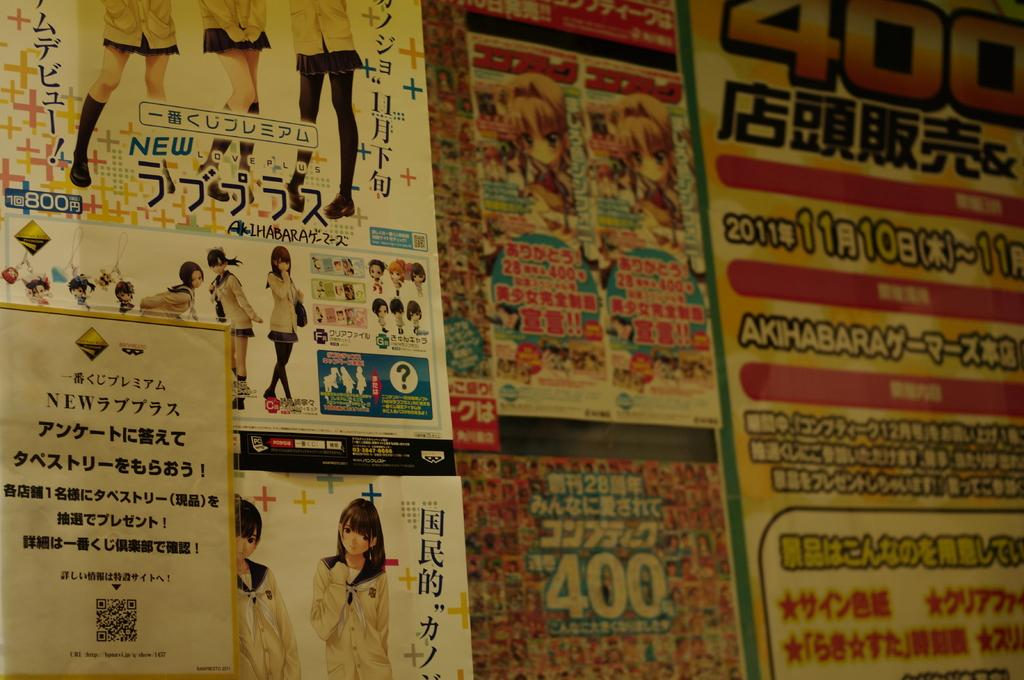<image>
Share a concise interpretation of the image provided. Many ads for something in Japanese, one of them includes the number 400. 